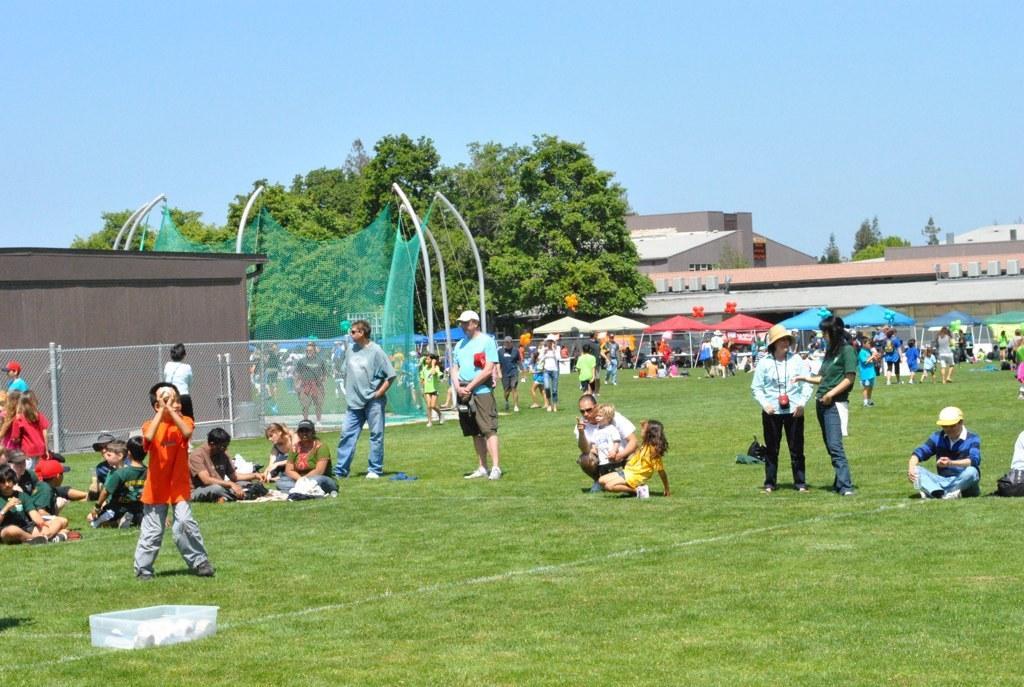Can you describe this image briefly? In this image, we can see the ground covered with grass and some objects. There are a few people. We can see the fence and some net. We can see some umbrellas. There are a few balloons and buildings. There are a few trees. We can see the sky. We can see some poles. 